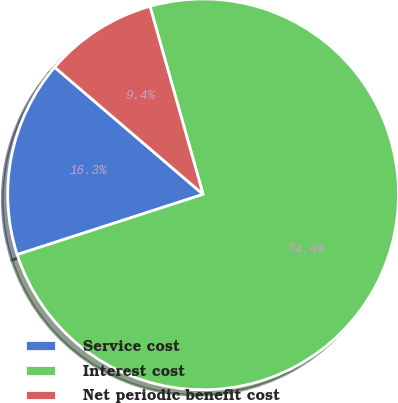Convert chart to OTSL. <chart><loc_0><loc_0><loc_500><loc_500><pie_chart><fcel>Service cost<fcel>Interest cost<fcel>Net periodic benefit cost<nl><fcel>16.26%<fcel>74.39%<fcel>9.35%<nl></chart> 